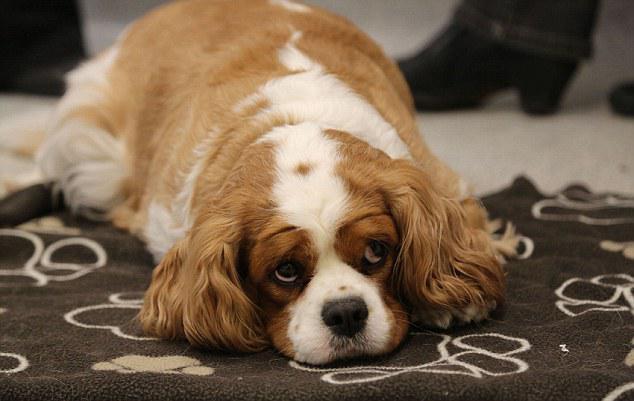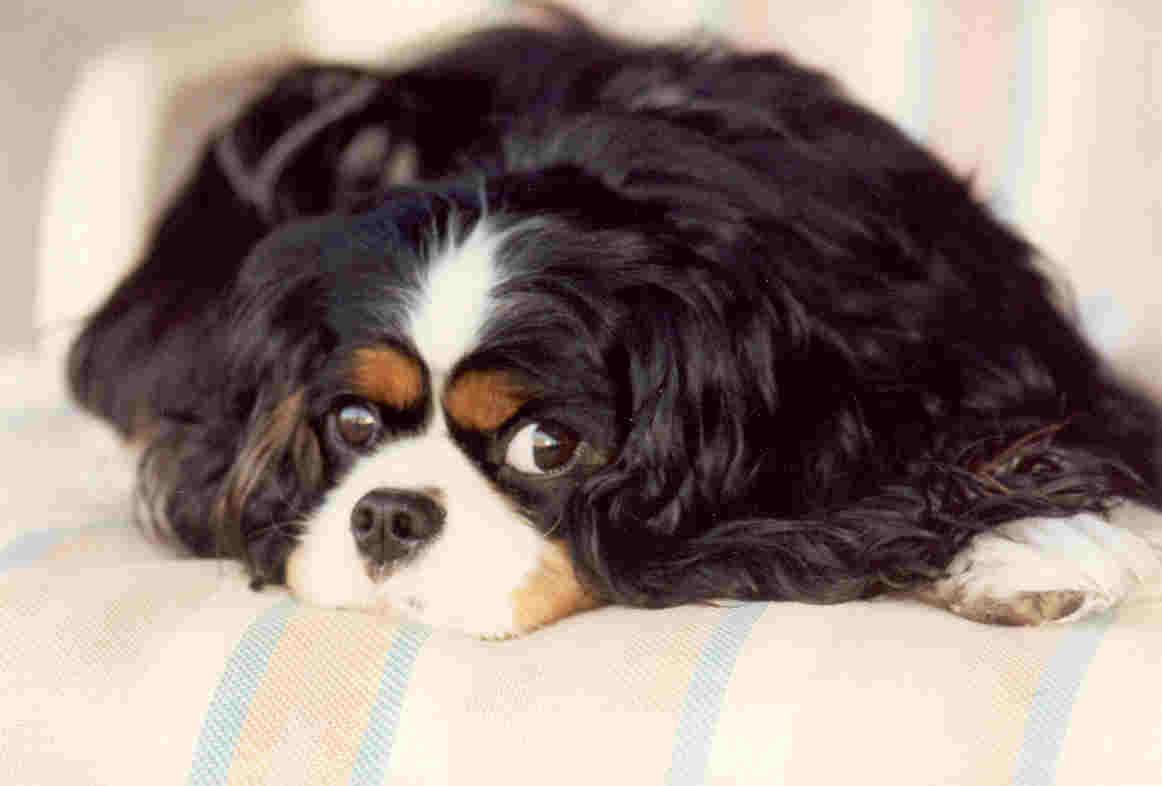The first image is the image on the left, the second image is the image on the right. For the images displayed, is the sentence "One image contains a brown-and-white spaniel next to a dog with darker markings, and the other image contains only one brown-and-white spaniel." factually correct? Answer yes or no. No. The first image is the image on the left, the second image is the image on the right. Examine the images to the left and right. Is the description "There are exactly two dogs in the left image." accurate? Answer yes or no. No. 